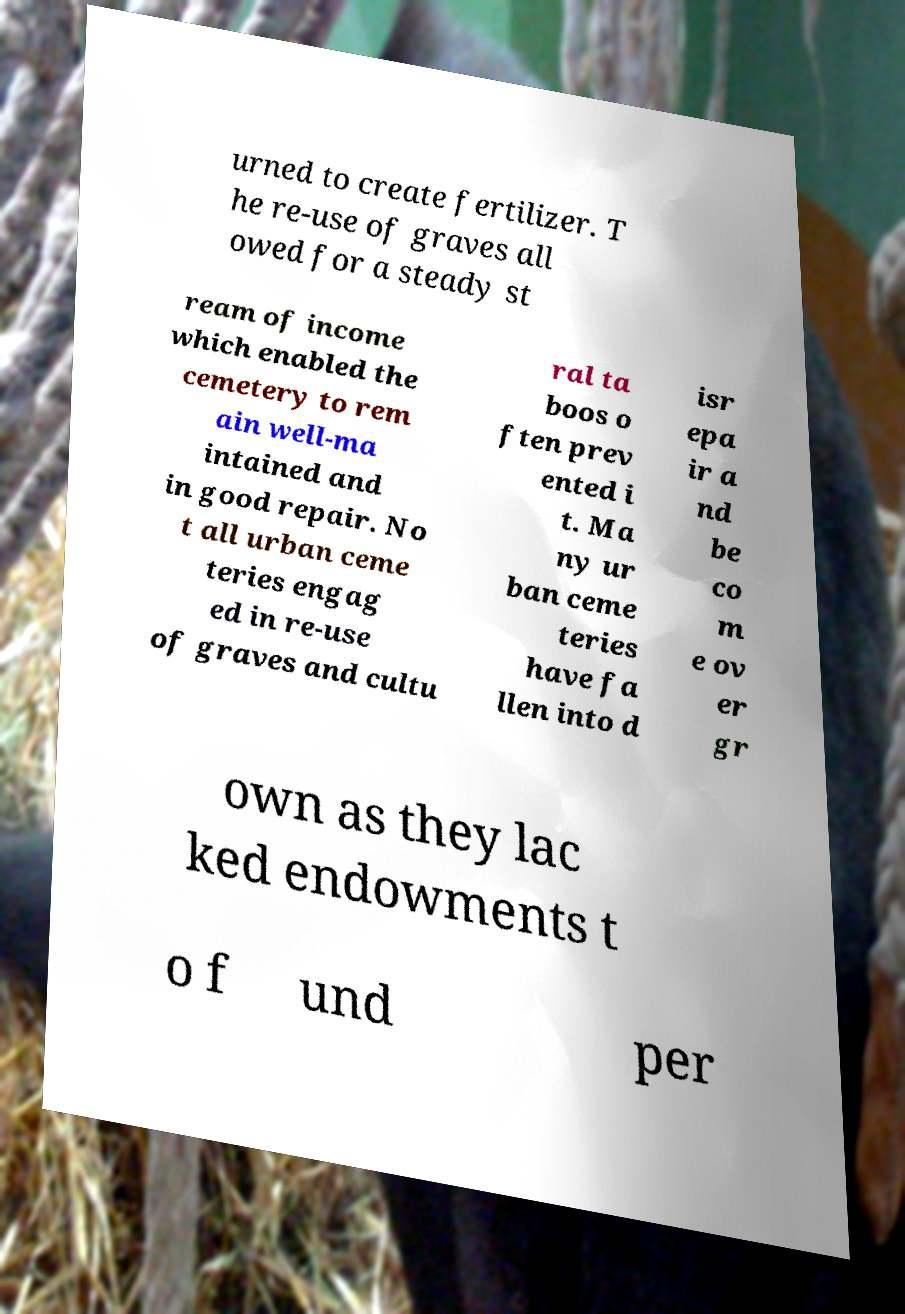There's text embedded in this image that I need extracted. Can you transcribe it verbatim? urned to create fertilizer. T he re-use of graves all owed for a steady st ream of income which enabled the cemetery to rem ain well-ma intained and in good repair. No t all urban ceme teries engag ed in re-use of graves and cultu ral ta boos o ften prev ented i t. Ma ny ur ban ceme teries have fa llen into d isr epa ir a nd be co m e ov er gr own as they lac ked endowments t o f und per 